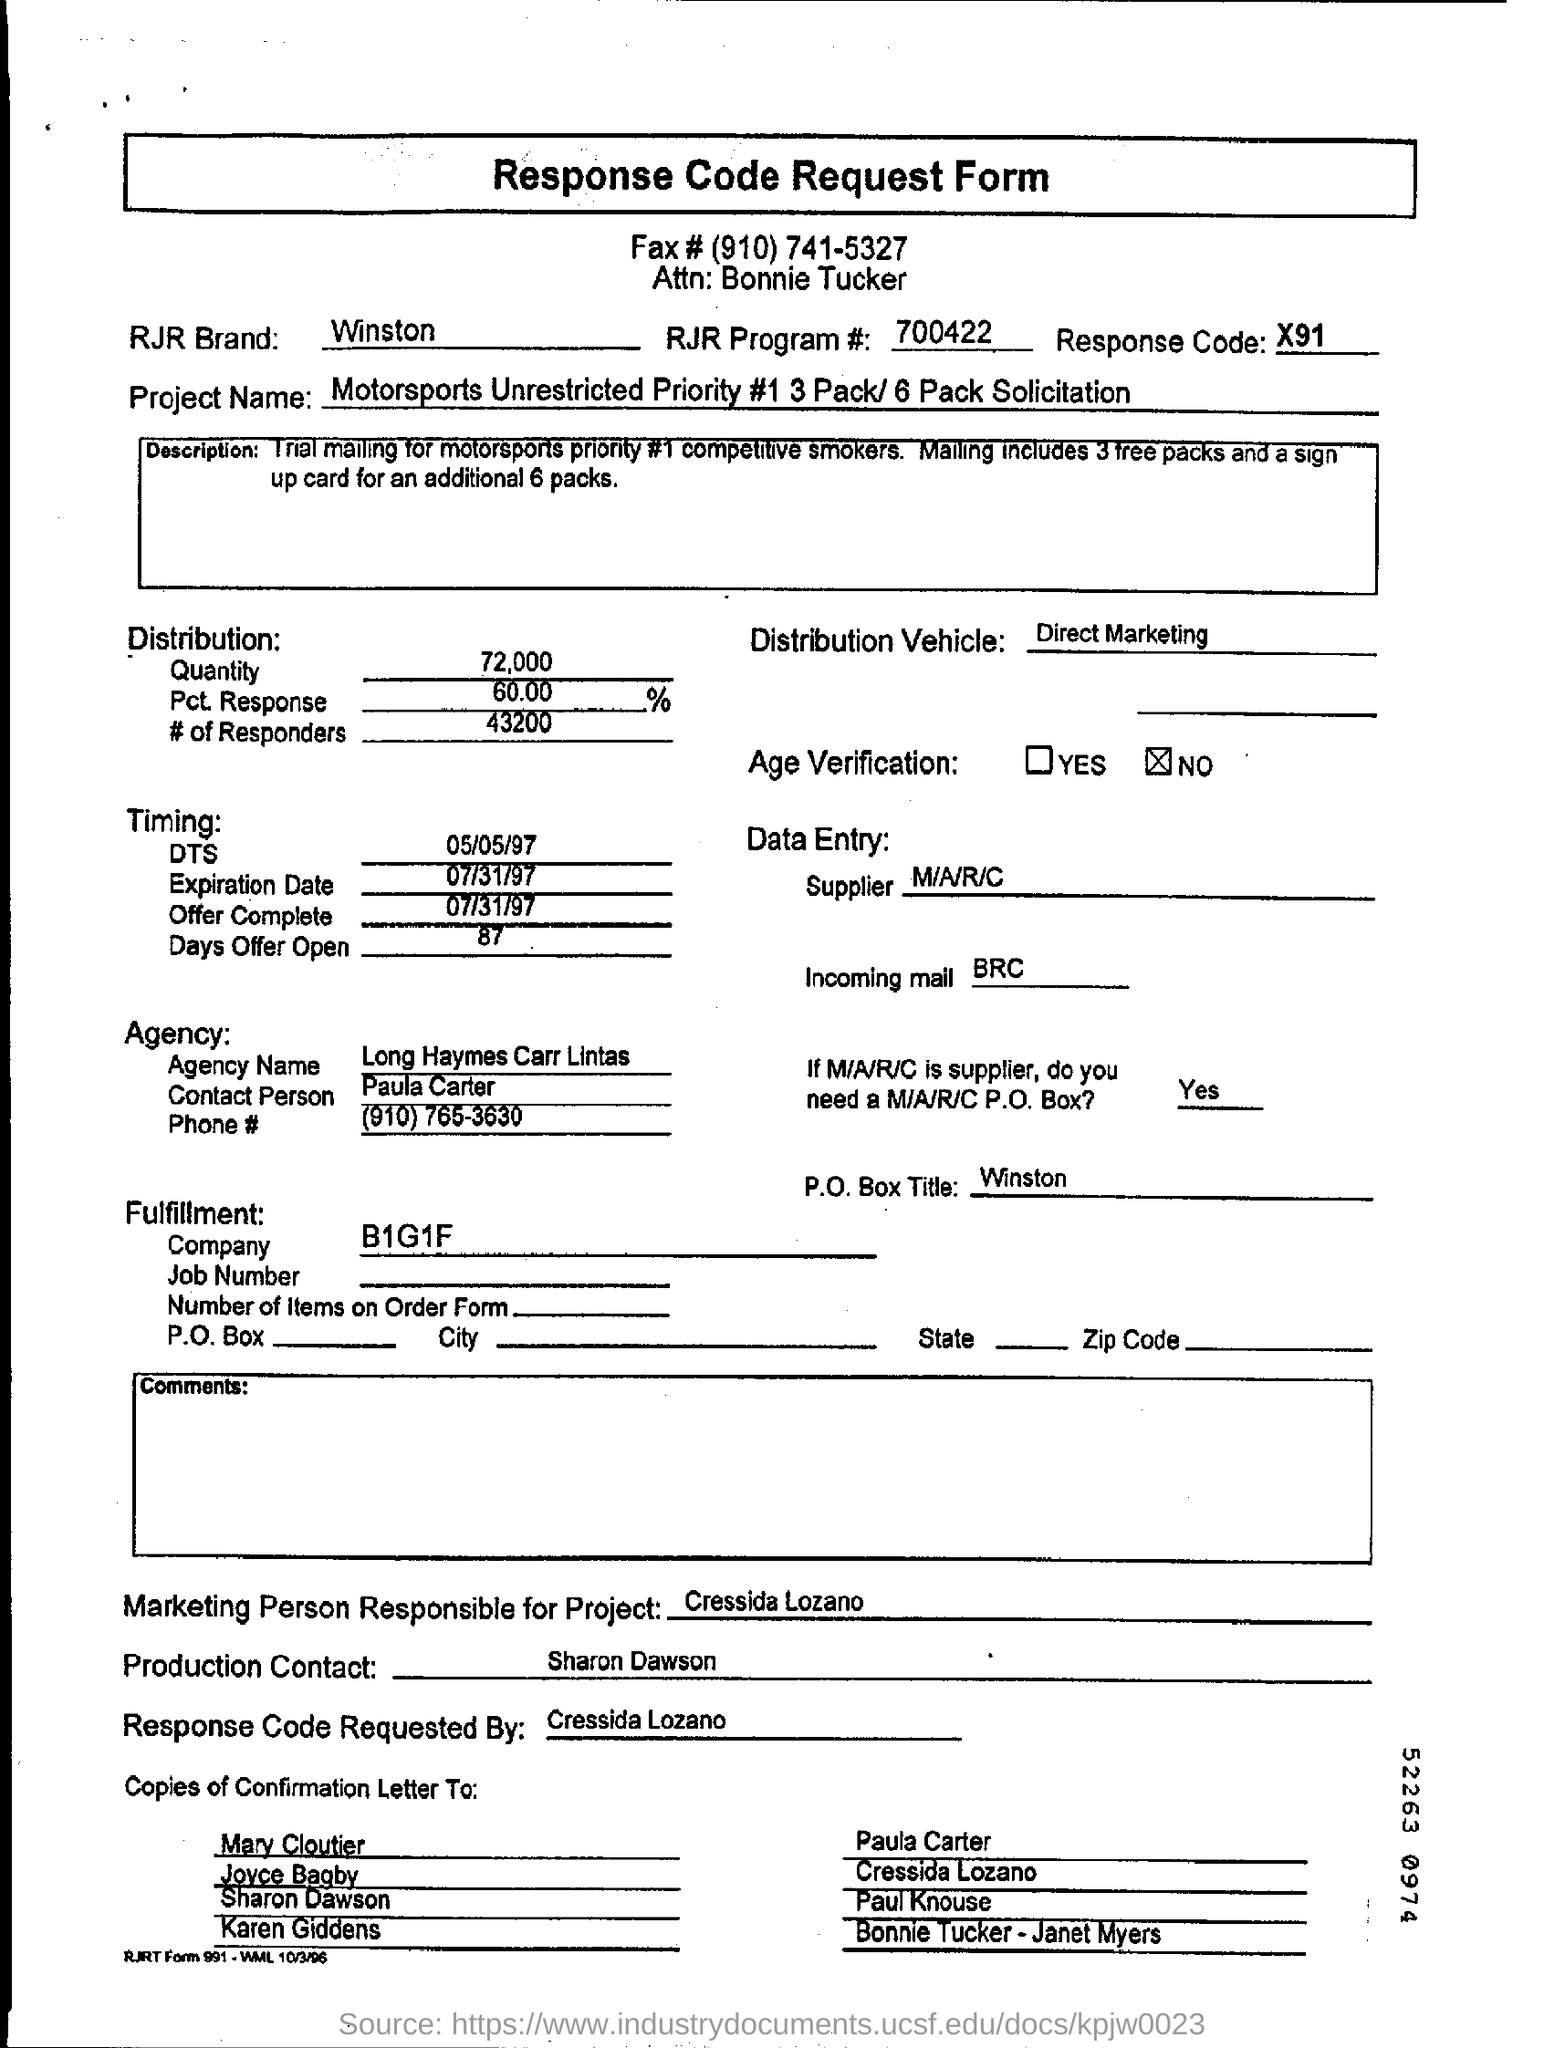Indicate a few pertinent items in this graphic. Long Haymes Carr Lintas is the agency name mentioned. The fax number mentioned is (910) 741-5327. What is the response code mentioned? X91..." is a question asking for information about a specific code. The brand RJR is mentioned as WINSTON. The DTS timing mentioned is May 5th, 1997. 